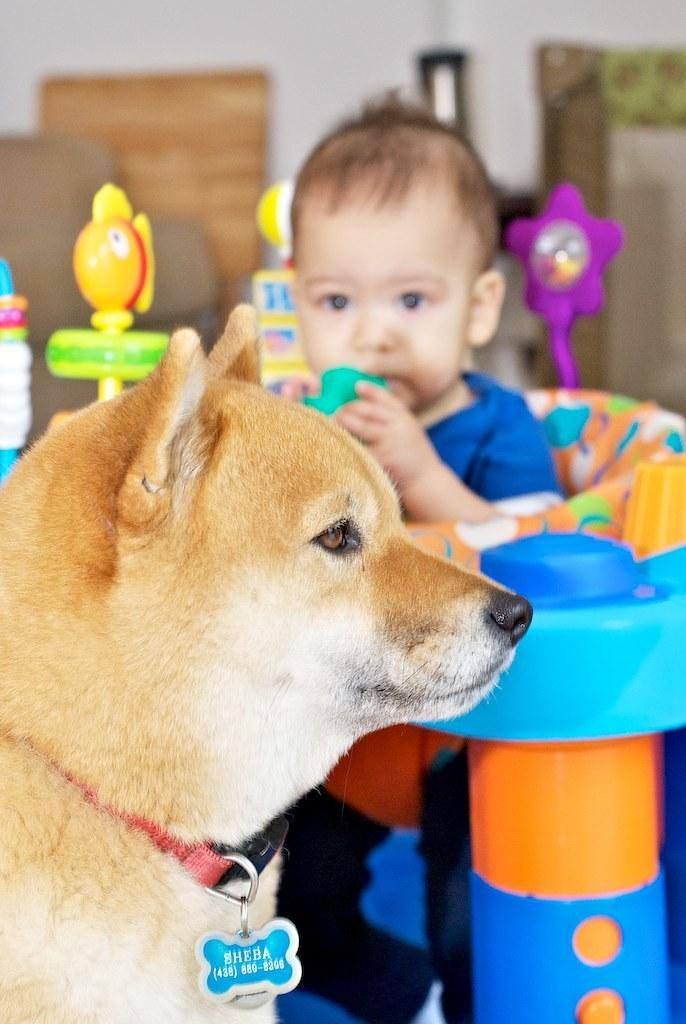What animal is present in the image? There is a dog in the image. What is the dog wearing around its neck? The dog has a belt around its neck. Who else is present in the image? There is a boy in the image. What is the boy doing in the image? The boy is sitting in a baby walker. What is the boy holding in the image? The boy is holding a toy. What else can be seen around the boy in the image? There is a group of toys around the boy. What type of war is depicted in the image? There is no war depicted in the image; it features a dog and a boy with toys. What kind of wave can be seen in the image? There is no wave present in the image; it is a still image of a dog and a boy with toys. 